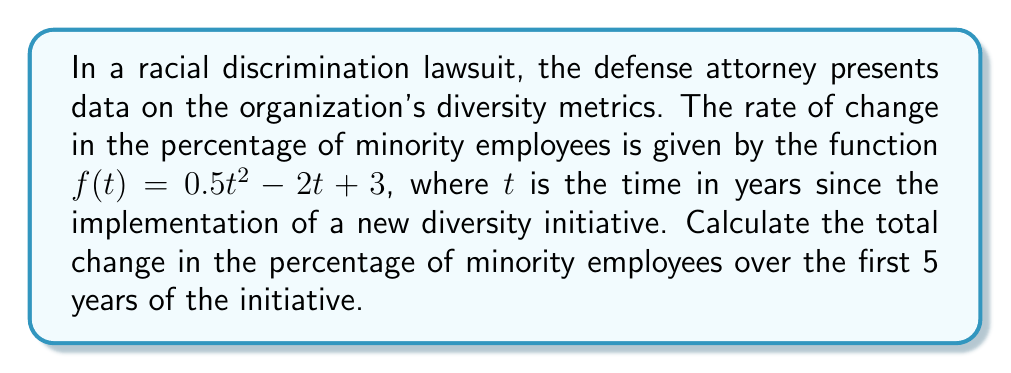Can you solve this math problem? To find the total change in the percentage of minority employees over the first 5 years, we need to calculate the definite integral of the rate of change function from $t=0$ to $t=5$.

1) The given rate of change function is:
   $f(t) = 0.5t^2 - 2t + 3$

2) We need to integrate this function from 0 to 5:
   $$\int_0^5 (0.5t^2 - 2t + 3) dt$$

3) Integrate each term:
   $$\left[\frac{0.5t^3}{3} - t^2 + 3t\right]_0^5$$

4) Evaluate the integral at the upper and lower bounds:
   $$\left(\frac{0.5(5^3)}{3} - 5^2 + 3(5)\right) - \left(\frac{0.5(0^3)}{3} - 0^2 + 3(0)\right)$$

5) Simplify:
   $$\left(\frac{125}{3} - 25 + 15\right) - (0)$$
   $$= \frac{125}{3} - 10$$
   $$= \frac{125}{3} - \frac{30}{3}$$
   $$= \frac{95}{3}$$

6) The result, $\frac{95}{3}$, represents the total change in the percentage of minority employees over the 5-year period.
Answer: $\frac{95}{3}$ percentage points 